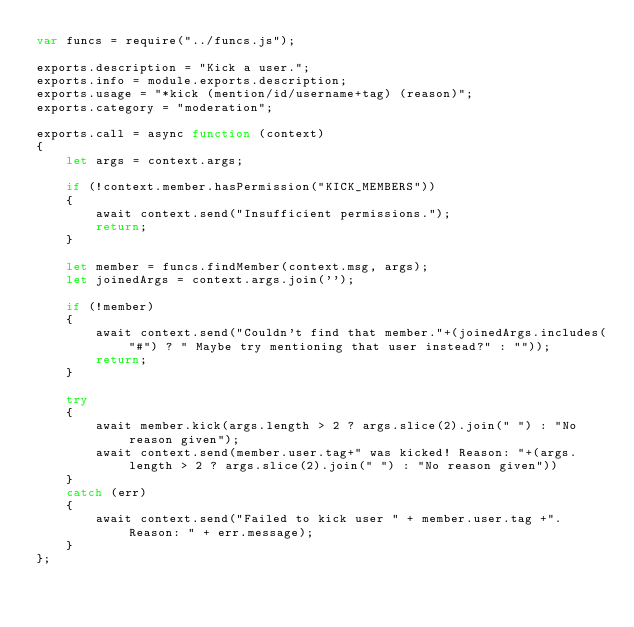<code> <loc_0><loc_0><loc_500><loc_500><_JavaScript_>var funcs = require("../funcs.js");

exports.description = "Kick a user.";
exports.info = module.exports.description;
exports.usage = "*kick (mention/id/username+tag) (reason)";
exports.category = "moderation";

exports.call = async function (context)
{
    let args = context.args;

    if (!context.member.hasPermission("KICK_MEMBERS"))
    {
        await context.send("Insufficient permissions.");
        return;
    }

    let member = funcs.findMember(context.msg, args);
    let joinedArgs = context.args.join('');

    if (!member)
    {
        await context.send("Couldn't find that member."+(joinedArgs.includes("#") ? " Maybe try mentioning that user instead?" : ""));
        return;
    }

    try
    {
        await member.kick(args.length > 2 ? args.slice(2).join(" ") : "No reason given");
        await context.send(member.user.tag+" was kicked! Reason: "+(args.length > 2 ? args.slice(2).join(" ") : "No reason given"))
    }
    catch (err)
    {
        await context.send("Failed to kick user " + member.user.tag +". Reason: " + err.message);
    }
};
</code> 